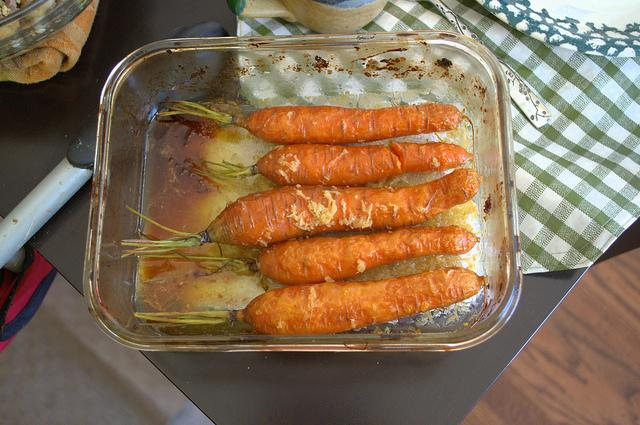Where did the food in the dish come from?

Choices:
A) sky
B) ground
C) elephant waste
D) rock ground 